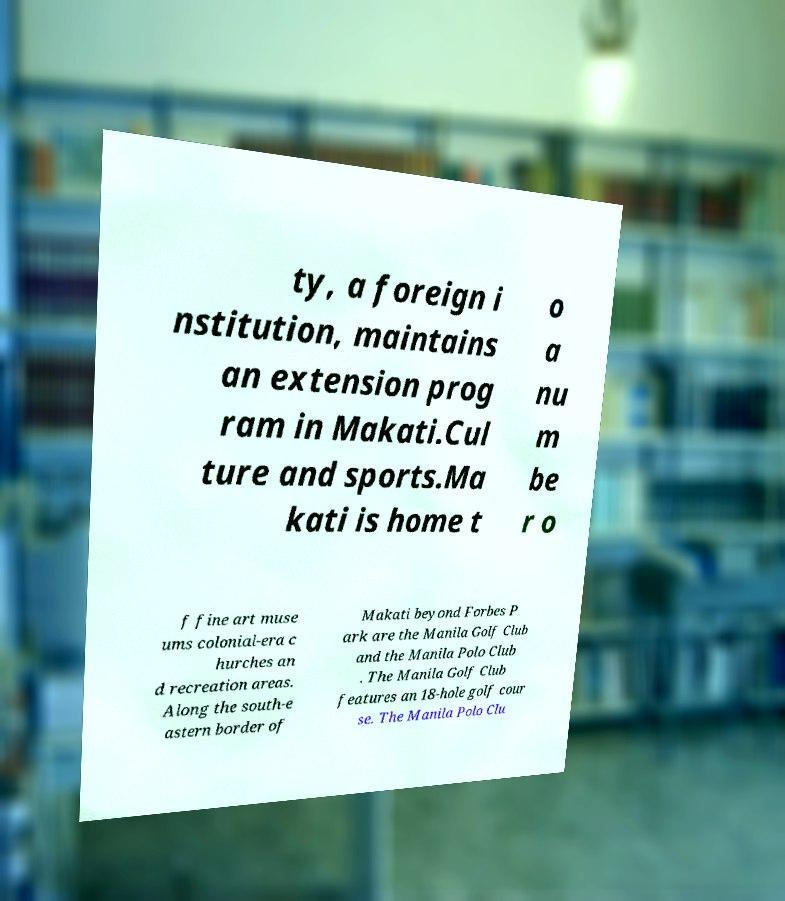Please read and relay the text visible in this image. What does it say? ty, a foreign i nstitution, maintains an extension prog ram in Makati.Cul ture and sports.Ma kati is home t o a nu m be r o f fine art muse ums colonial-era c hurches an d recreation areas. Along the south-e astern border of Makati beyond Forbes P ark are the Manila Golf Club and the Manila Polo Club . The Manila Golf Club features an 18-hole golf cour se. The Manila Polo Clu 